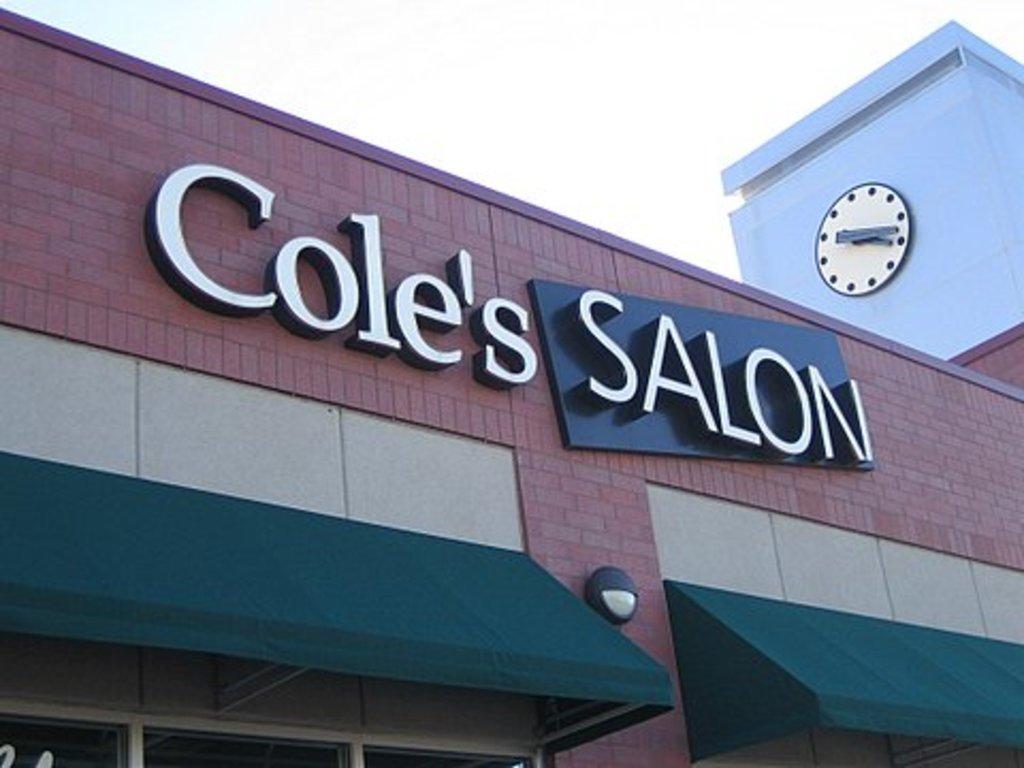Who does the salon belong to?
Make the answer very short. Cole. Who owns this salon?
Your answer should be very brief. Cole. 